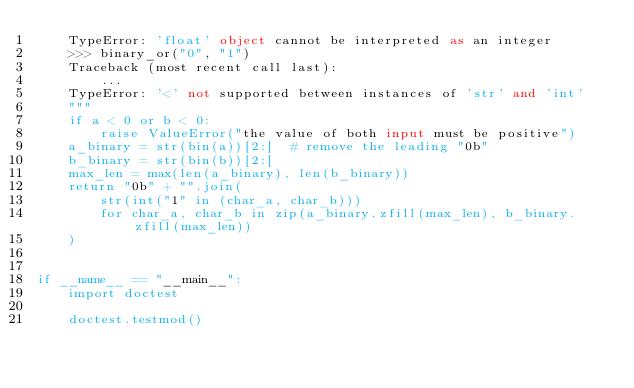<code> <loc_0><loc_0><loc_500><loc_500><_Python_>    TypeError: 'float' object cannot be interpreted as an integer
    >>> binary_or("0", "1")
    Traceback (most recent call last):
        ...
    TypeError: '<' not supported between instances of 'str' and 'int'
    """
    if a < 0 or b < 0:
        raise ValueError("the value of both input must be positive")
    a_binary = str(bin(a))[2:]  # remove the leading "0b"
    b_binary = str(bin(b))[2:]
    max_len = max(len(a_binary), len(b_binary))
    return "0b" + "".join(
        str(int("1" in (char_a, char_b)))
        for char_a, char_b in zip(a_binary.zfill(max_len), b_binary.zfill(max_len))
    )


if __name__ == "__main__":
    import doctest

    doctest.testmod()
</code> 